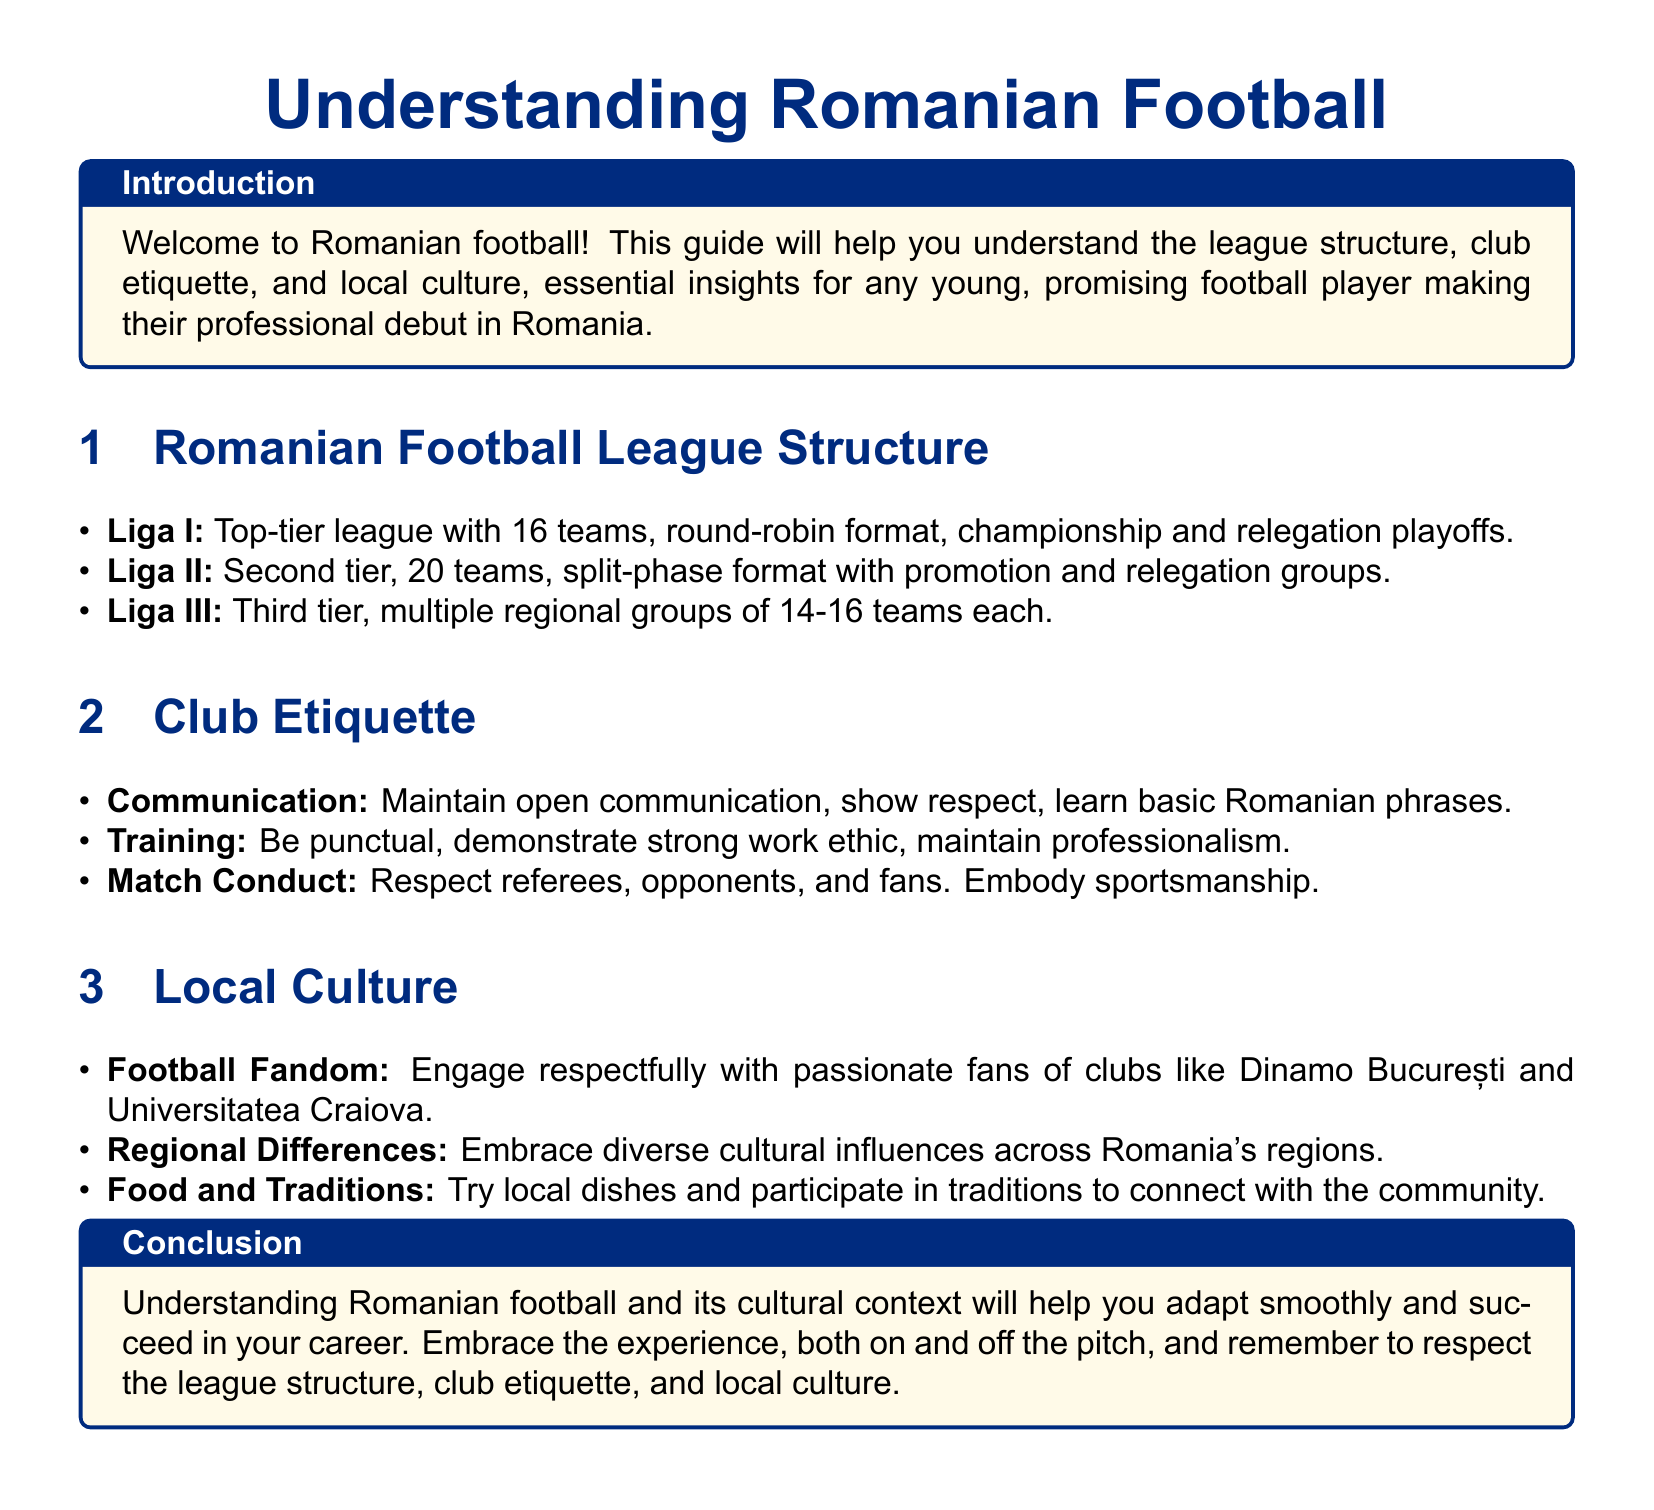What is the top-tier league in Romanian football? The top-tier league in Romanian football is Liga I, as stated in the league structure section of the document.
Answer: Liga I How many teams are in Liga II? Liga II consists of 20 teams, according to the document's description of the league structure.
Answer: 20 teams What should you show in communication with club members? The document highlights the importance of showing respect in communication with club members.
Answer: Respect What is a key aspect of club training etiquette? Being punctual is emphasized as a key aspect of club training etiquette in the document.
Answer: Punctuality Which club is mentioned as having passionate fans? The document mentions Dinamo București as a club with passionate fans under local culture.
Answer: Dinamo București How many teams participate in Liga I? Liga I has 16 teams participating, as indicated in the league structure section.
Answer: 16 teams What type of format does Liga II use? Liga II uses a split-phase format, according to information in the document.
Answer: Split-phase format What is the local cuisine experience suggested in the document? The document encourages trying local dishes as part of engaging with the community.
Answer: Local dishes Why is understanding local culture important for a football player? Understanding local culture helps in adapting smoothly according to the conclusion section of the document.
Answer: Adapting smoothly 